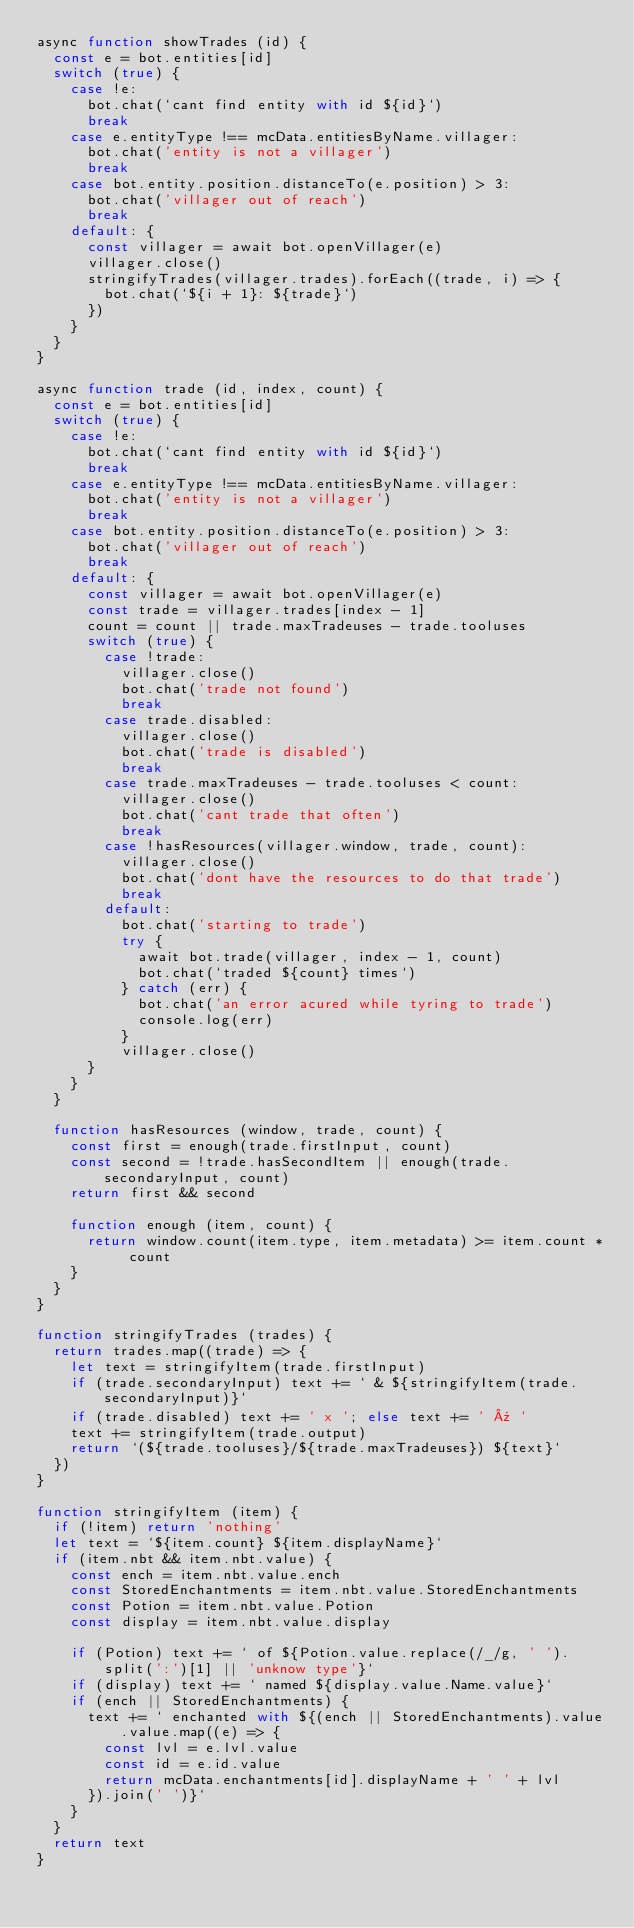Convert code to text. <code><loc_0><loc_0><loc_500><loc_500><_JavaScript_>async function showTrades (id) {
  const e = bot.entities[id]
  switch (true) {
    case !e:
      bot.chat(`cant find entity with id ${id}`)
      break
    case e.entityType !== mcData.entitiesByName.villager:
      bot.chat('entity is not a villager')
      break
    case bot.entity.position.distanceTo(e.position) > 3:
      bot.chat('villager out of reach')
      break
    default: {
      const villager = await bot.openVillager(e)
      villager.close()
      stringifyTrades(villager.trades).forEach((trade, i) => {
        bot.chat(`${i + 1}: ${trade}`)
      })
    }
  }
}

async function trade (id, index, count) {
  const e = bot.entities[id]
  switch (true) {
    case !e:
      bot.chat(`cant find entity with id ${id}`)
      break
    case e.entityType !== mcData.entitiesByName.villager:
      bot.chat('entity is not a villager')
      break
    case bot.entity.position.distanceTo(e.position) > 3:
      bot.chat('villager out of reach')
      break
    default: {
      const villager = await bot.openVillager(e)
      const trade = villager.trades[index - 1]
      count = count || trade.maxTradeuses - trade.tooluses
      switch (true) {
        case !trade:
          villager.close()
          bot.chat('trade not found')
          break
        case trade.disabled:
          villager.close()
          bot.chat('trade is disabled')
          break
        case trade.maxTradeuses - trade.tooluses < count:
          villager.close()
          bot.chat('cant trade that often')
          break
        case !hasResources(villager.window, trade, count):
          villager.close()
          bot.chat('dont have the resources to do that trade')
          break
        default:
          bot.chat('starting to trade')
          try {
            await bot.trade(villager, index - 1, count)
            bot.chat(`traded ${count} times`)
          } catch (err) {
            bot.chat('an error acured while tyring to trade')
            console.log(err)
          }
          villager.close()
      }
    }
  }

  function hasResources (window, trade, count) {
    const first = enough(trade.firstInput, count)
    const second = !trade.hasSecondItem || enough(trade.secondaryInput, count)
    return first && second

    function enough (item, count) {
      return window.count(item.type, item.metadata) >= item.count * count
    }
  }
}

function stringifyTrades (trades) {
  return trades.map((trade) => {
    let text = stringifyItem(trade.firstInput)
    if (trade.secondaryInput) text += ` & ${stringifyItem(trade.secondaryInput)}`
    if (trade.disabled) text += ' x '; else text += ' » '
    text += stringifyItem(trade.output)
    return `(${trade.tooluses}/${trade.maxTradeuses}) ${text}`
  })
}

function stringifyItem (item) {
  if (!item) return 'nothing'
  let text = `${item.count} ${item.displayName}`
  if (item.nbt && item.nbt.value) {
    const ench = item.nbt.value.ench
    const StoredEnchantments = item.nbt.value.StoredEnchantments
    const Potion = item.nbt.value.Potion
    const display = item.nbt.value.display

    if (Potion) text += ` of ${Potion.value.replace(/_/g, ' ').split(':')[1] || 'unknow type'}`
    if (display) text += ` named ${display.value.Name.value}`
    if (ench || StoredEnchantments) {
      text += ` enchanted with ${(ench || StoredEnchantments).value.value.map((e) => {
        const lvl = e.lvl.value
        const id = e.id.value
        return mcData.enchantments[id].displayName + ' ' + lvl
      }).join(' ')}`
    }
  }
  return text
}
</code> 